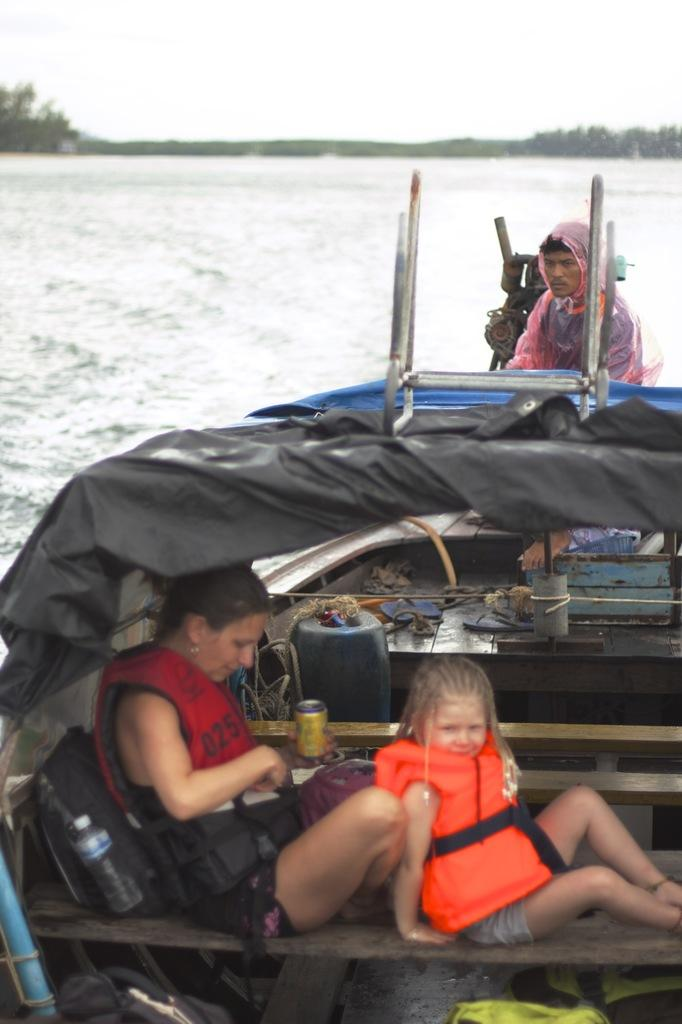What can be seen at the top of the image? The sky, trees, and water are visible at the top of the image. What is located at the bottom of the image? There is a boat at the bottom of the image. How many people are in the boat? There are three people in the boat. What are two of the people in the boat wearing? Two of the people in the boat are wearing backpacks. Can you see a gun in the hands of any of the people in the boat? There is no gun present in the image. What type of drug is being used by the people in the boat? There is no drug use depicted in the image. 